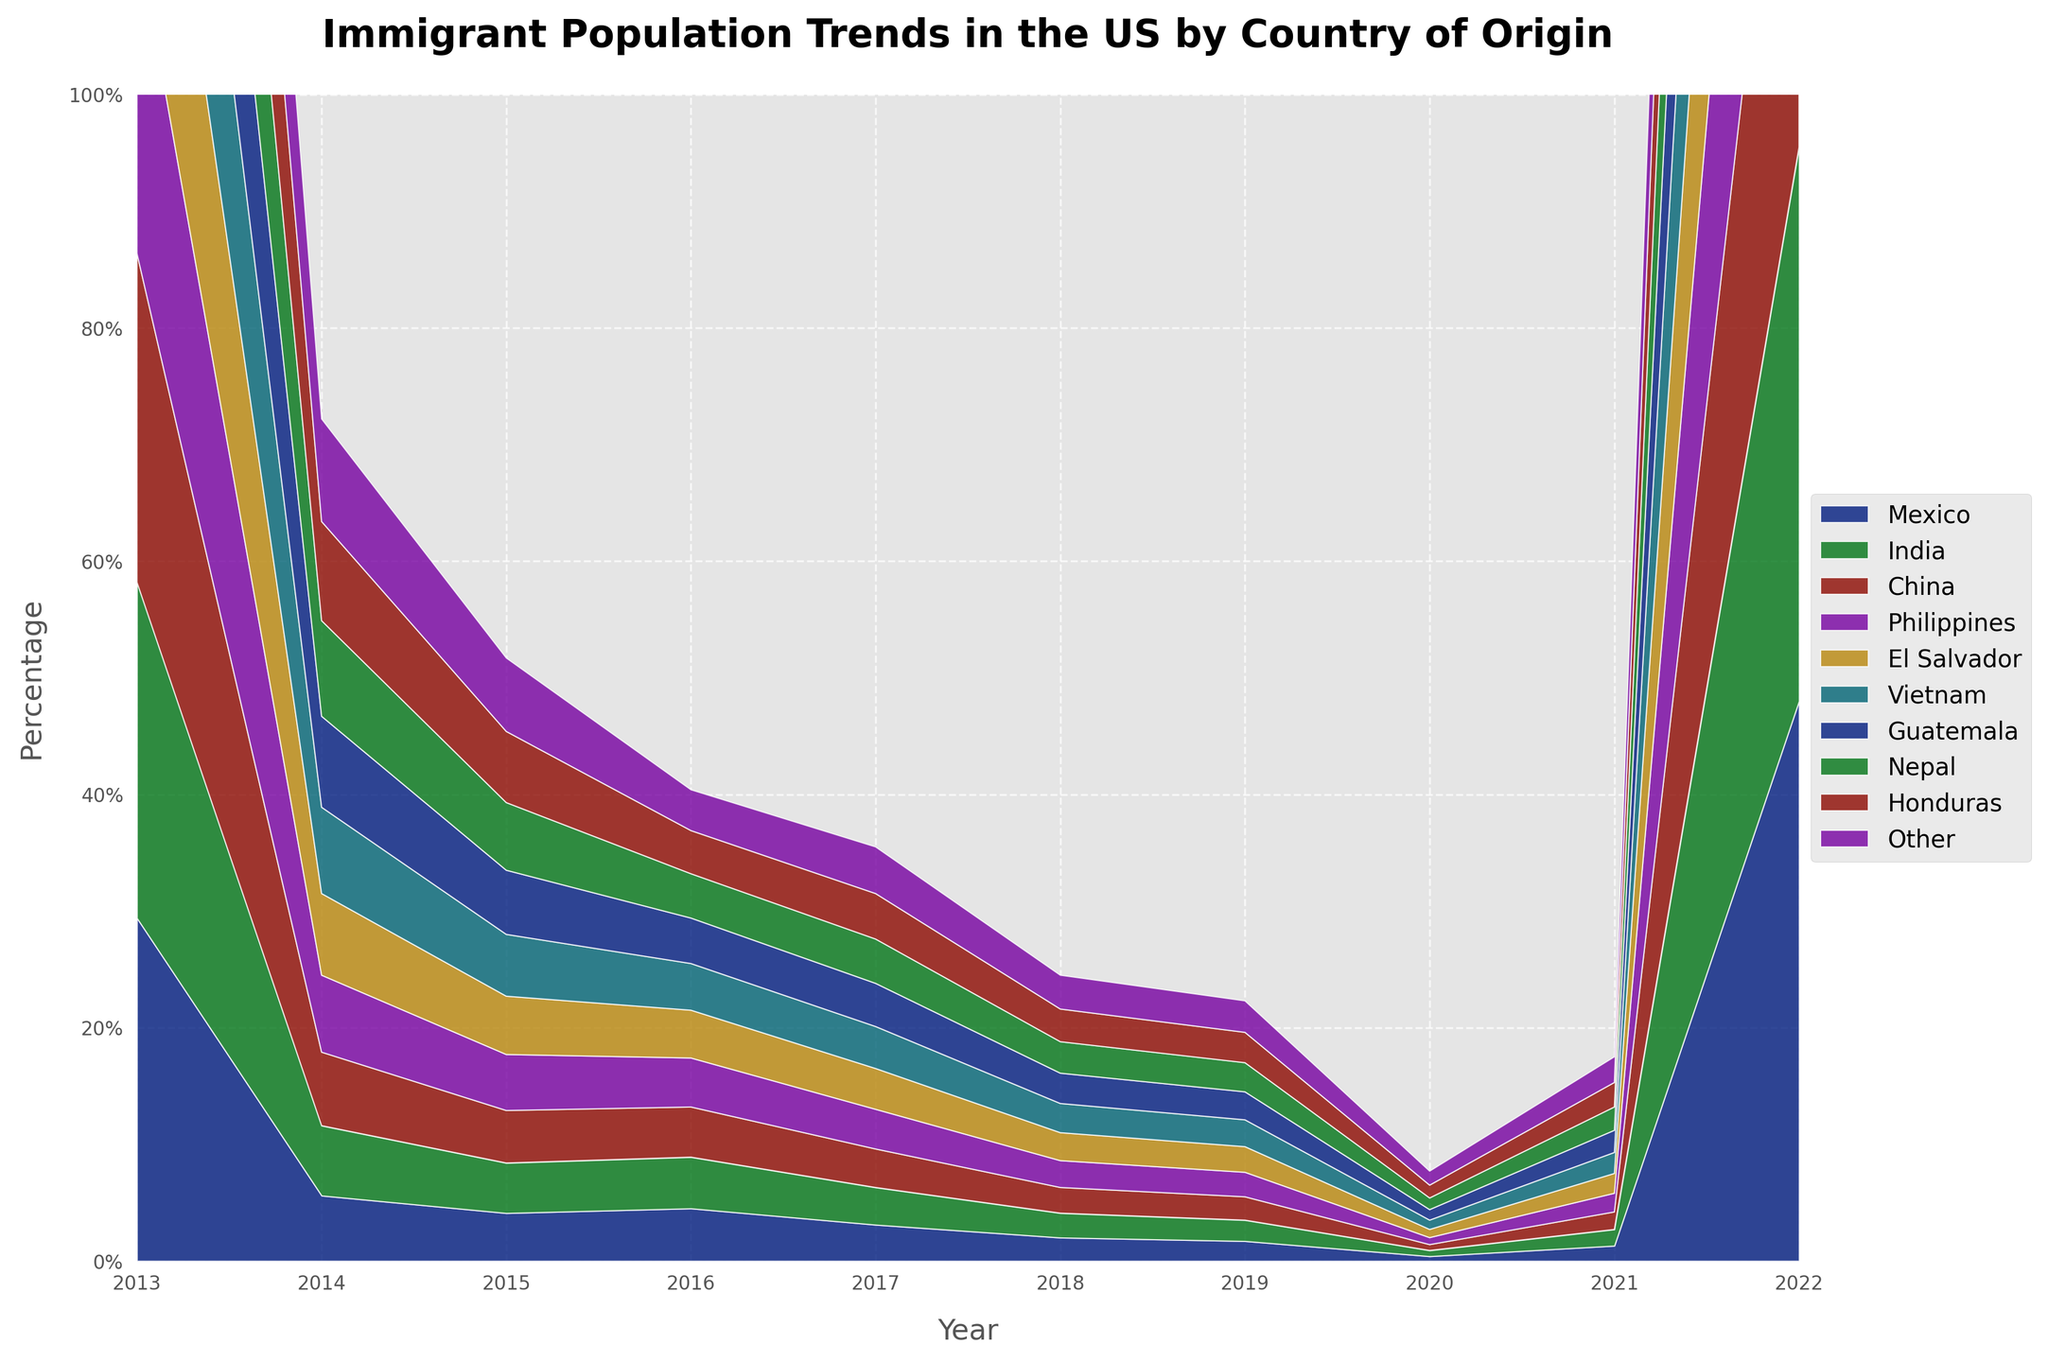What is the title of the chart? The title of the chart is located at the top and it clearly states the subject of the figure.
Answer: Immigrant Population Trends in the US by Country of Origin Which country had the highest immigrant population percentage in 2013? By looking at the 2013 segment of the chart, the largest area is at the bottom, representing Mexico.
Answer: Mexico How has the immigrant population percentage from Mexico changed from 2013 to 2022? To find this, locate the Mexico data and note its percentage in 2013 and 2022. Subtract the later value from the initial value: 29.4% - 25.4%.
Answer: It decreased by 4% Which country showed a continuous increase in its immigrant population percentage over the years? By examining the trends for each country, India shows a consistent upward trend from 5.6% in 2013 to 8.8% in 2022.
Answer: India Between which two consecutive years did China have the largest increase in its immigrant population percentage? Observe the increments for China year by year. From 2016 to 2017, it increased from 4.8% to 5.0%, the largest increment noticed.
Answer: 2016-2017 Which country had a higher immigrant population percentage in 2022, El Salvador or Vietnam? Look at the respective values for 2022 for El Salvador and Vietnam. El Salvador had 4.0% and Vietnam had 2.9%.
Answer: El Salvador What is the combined percentage of immigrant populations from India and Nepal in 2022? Sum the percentages for India (8.8%) and Nepal (1.2%) in 2022. 8.8% + 1.2%.
Answer: 10% Which country had a decrease in its immigrant population percentage every year? The Philippines had a consistent year-over-year decrease from 4.5% in 2013 to 3.5% in 2022.
Answer: Philippines How does the area representing "Other" countries change over the years? Look at how the distribution for "Other" shifts from the start (48.0% in 2013) to the end (43% in 2022). The area compresses, representing a decrease.
Answer: It decreased Which three countries had the smallest immigrant population percentages in 2013? Check the smallest stacked areas at the start of the timeline for 2013. The smallest portions are for Nepal (0.4%), Honduras (1.3%), and Guatemala (1.7%).
Answer: Nepal, Honduras, Guatemala 